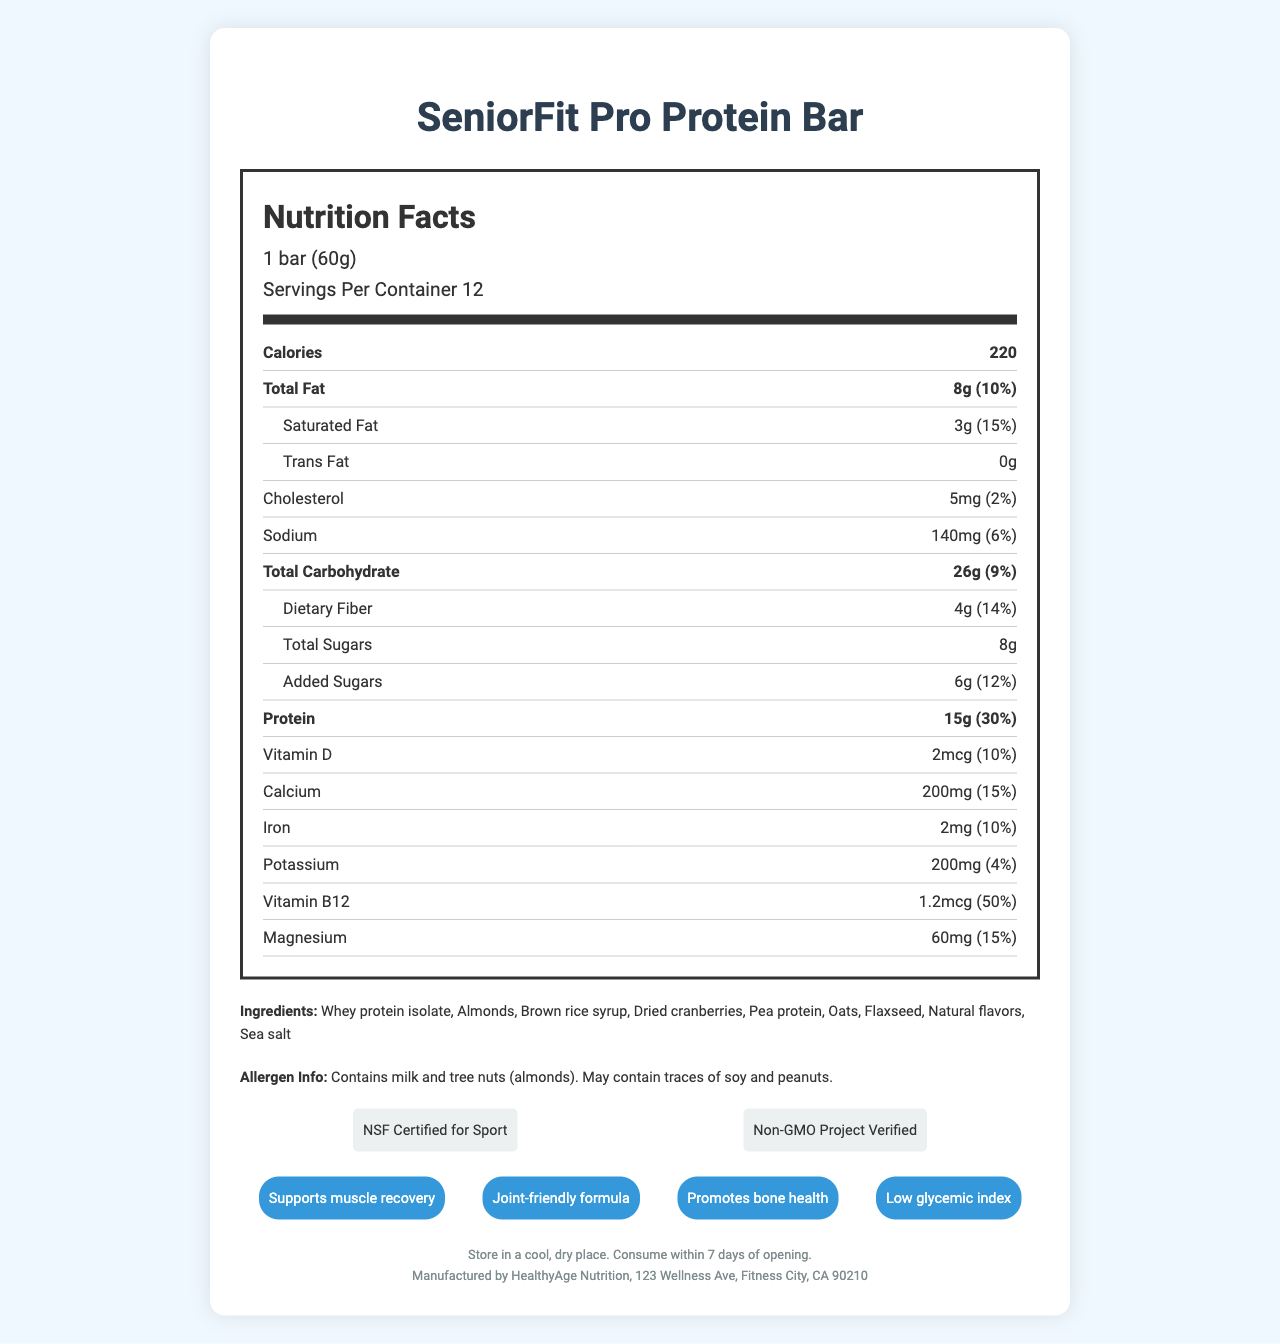what is the name of the protein bar? The product name is clearly labeled at the top of the document.
Answer: SeniorFit Pro Protein Bar how many servings are in each container? The document specifies that there are 12 servings per container.
Answer: 12 how many calories are in one serving? The document lists the calories per serving as 220.
Answer: 220 how much total fat is in one serving? Under the "Total Fat" section, the document states the amount per serving is 8g.
Answer: 8g which ingredient contains tree nuts? The allergen info mentions tree nuts (almonds).
Answer: Almonds How much protein does one bar contain? The document states that each bar contains 15g of protein.
Answer: 15g what is the daily value percentage of vitamin B12? The daily value percentage of vitamin B12 is listed as 50%.
Answer: 50% which certification does the protein bar have? A. Organic B. Non-GMO Project Verified C. Gluten-Free D. Kosher The document lists "Non-GMO Project Verified" as one of the certifications.
Answer: B what is the claim related to muscle? A. Promotes bone health B. Supports muscle recovery C. Joint-friendly formula D. Low glycemic index One of the marketing claims listed is "Supports muscle recovery".
Answer: B Does this product contain peanuts? The allergen info notes that the product may contain traces of peanuts.
Answer: May contain traces of peanuts Describe the main idea of the document. This summary encapsulates the key elements presented in the Nutrition Facts label.
Answer: The document is a detailed Nutrition Facts label for the "SeniorFit Pro Protein Bar," which is specifically targeted towards senior athletes. It includes information about serving size, nutritional content, ingredients, allergen info, certifications, marketing claims, storage instructions, and manufacturer details. What is the amount of magnesium in one serving? The document states that one serving contains 60mg of magnesium.
Answer: 60mg Which ingredient is used as a sweetener? Brown rice syrup is listed as one of the ingredients and is commonly used as a sweetener.
Answer: Brown rice syrup What is the daily value percentage of added sugars? The document shows that the daily value percentage for added sugars is 12%.
Answer: 12% Is the protein bar suitable for those who are lactose intolerant? The document indicates that the product contains milk, but does not provide enough information to ascertain if it is suitable for someone who is lactose intolerant, as it depends on the individual's level of intolerance.
Answer: Cannot be determined Where is the manufacturing company located? The document indicates that the manufacturer, HealthyAge Nutrition, is based in Fitness City, CA 90210.
Answer: Fitness City, CA 90210 